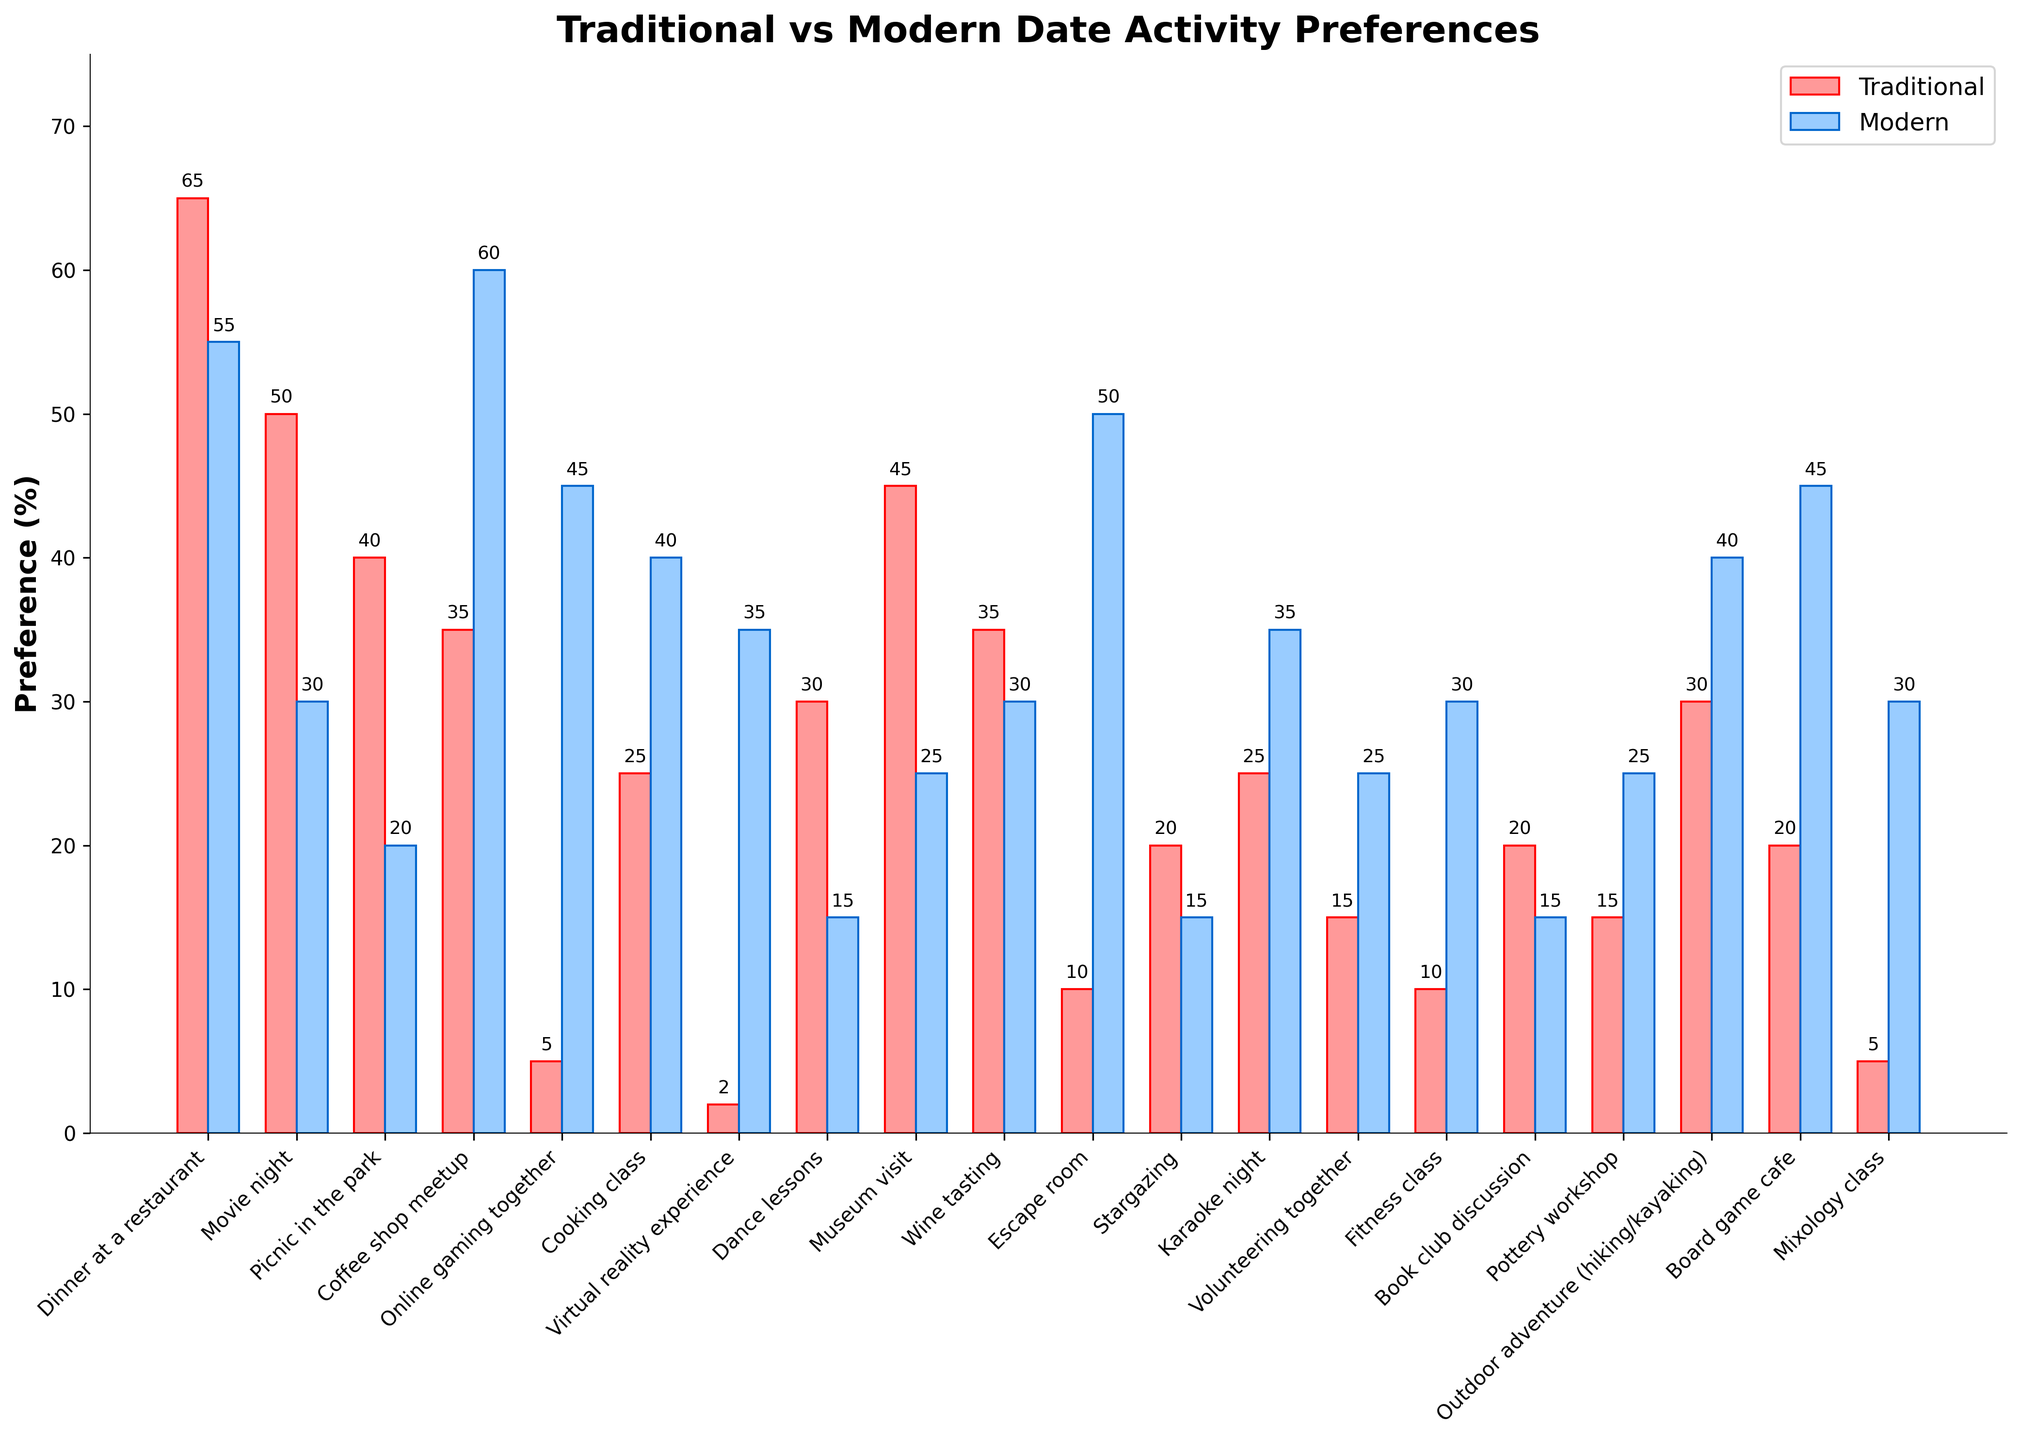What's the most preferred traditional date activity? The tallest red bar represents the most preferred traditional date activity. In this case, "Dinner at a restaurant" has the highest traditional preference at 65%.
Answer: Dinner at a restaurant How many activities have higher modern preference than traditional? Count the number of activities where the blue bar (modern) is taller than the red bar (traditional): Coffee shop meetup, Online gaming together, Cooking class, Virtual reality experience, Escape room, Karaoke night, Volunteering together, Fitness class, Pottery workshop, Outdoor adventure, Board game cafe, Mixology class
Answer: 12 activities Which activities are equally preferred in both traditional and modern preferences? Look for bars of equal height. In this case, no activities show equal preference percentages in both traditional and modern preferences.
Answer: None What is the least preferred traditional date activity? Identify the shortest red bar. "Virtual reality experience" has the lowest traditional preference at 2%.
Answer: Virtual reality experience What’s the average traditional and modern preference for "Wine tasting" and "Museum visit"? Calculate the average for each category: 
Traditional: (35% + 45%) / 2 = 40% 
Modern: (30% + 25%) / 2 = 27.5%
Answer: Traditional: 40%, Modern: 27.5% Which activities show a preference over 50% in modern dating? Identify activities with blue bars exceeding 50%. "Coffee shop meetup" (60%) and "Escape room" (50%) meet this criterion.
Answer: Coffee shop meetup, Escape room For "Cooking class," which preference is higher, and by how much? Compare the heights of the red and blue bars for "Cooking class." Modern preference (40%) is higher than traditional (25%) by 15%.
Answer: Modern by 15% What activities are more traditionally preferred than the "Escape room" modern preference? "Escape room" has a modern preference of 50%. Find all activities with traditional preference higher than 50%. Only "Dinner at a restaurant" has a traditional preference of 65%.
Answer: Dinner at a restaurant How many activities have a modern preference between 20% and 40%? Count bars where modern preference (blue) falls in the specified range: Museum visit, Wine tasting, Cooking class, Fitness class, Mixology class, Virtual reality experience, Volunteering together, Pottery workshop
Answer: 8 activities 